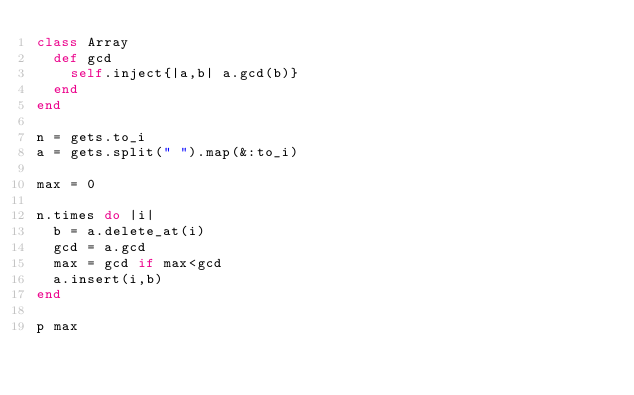<code> <loc_0><loc_0><loc_500><loc_500><_Ruby_>class Array
  def gcd
    self.inject{|a,b| a.gcd(b)}
  end
end

n = gets.to_i
a = gets.split(" ").map(&:to_i)

max = 0

n.times do |i|
  b = a.delete_at(i)
  gcd = a.gcd
  max = gcd if max<gcd
  a.insert(i,b)
end
  
p max
</code> 